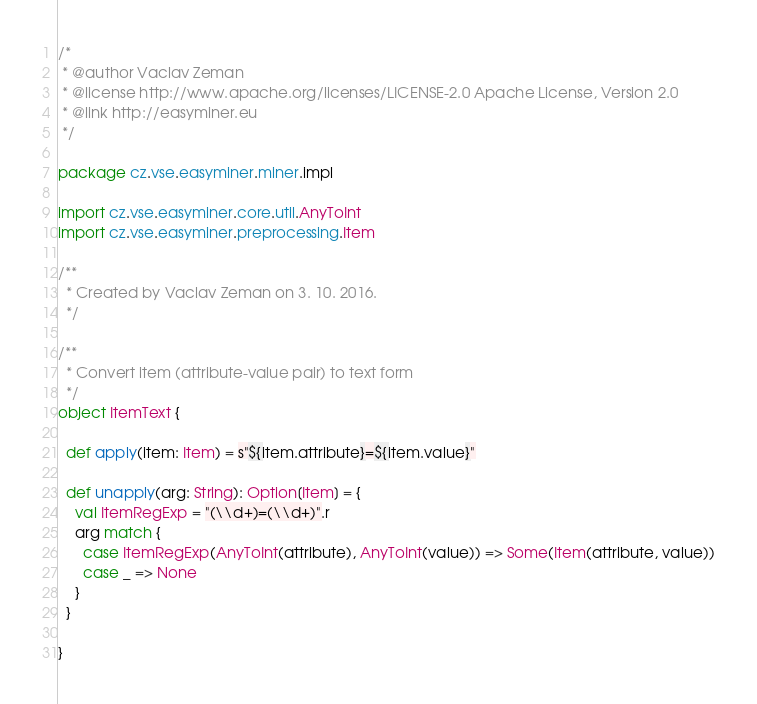Convert code to text. <code><loc_0><loc_0><loc_500><loc_500><_Scala_>/*
 * @author Vaclav Zeman
 * @license http://www.apache.org/licenses/LICENSE-2.0 Apache License, Version 2.0
 * @link http://easyminer.eu
 */

package cz.vse.easyminer.miner.impl

import cz.vse.easyminer.core.util.AnyToInt
import cz.vse.easyminer.preprocessing.Item

/**
  * Created by Vaclav Zeman on 3. 10. 2016.
  */

/**
  * Convert item (attribute-value pair) to text form
  */
object ItemText {

  def apply(item: Item) = s"${item.attribute}=${item.value}"

  def unapply(arg: String): Option[Item] = {
    val ItemRegExp = "(\\d+)=(\\d+)".r
    arg match {
      case ItemRegExp(AnyToInt(attribute), AnyToInt(value)) => Some(Item(attribute, value))
      case _ => None
    }
  }

}
</code> 